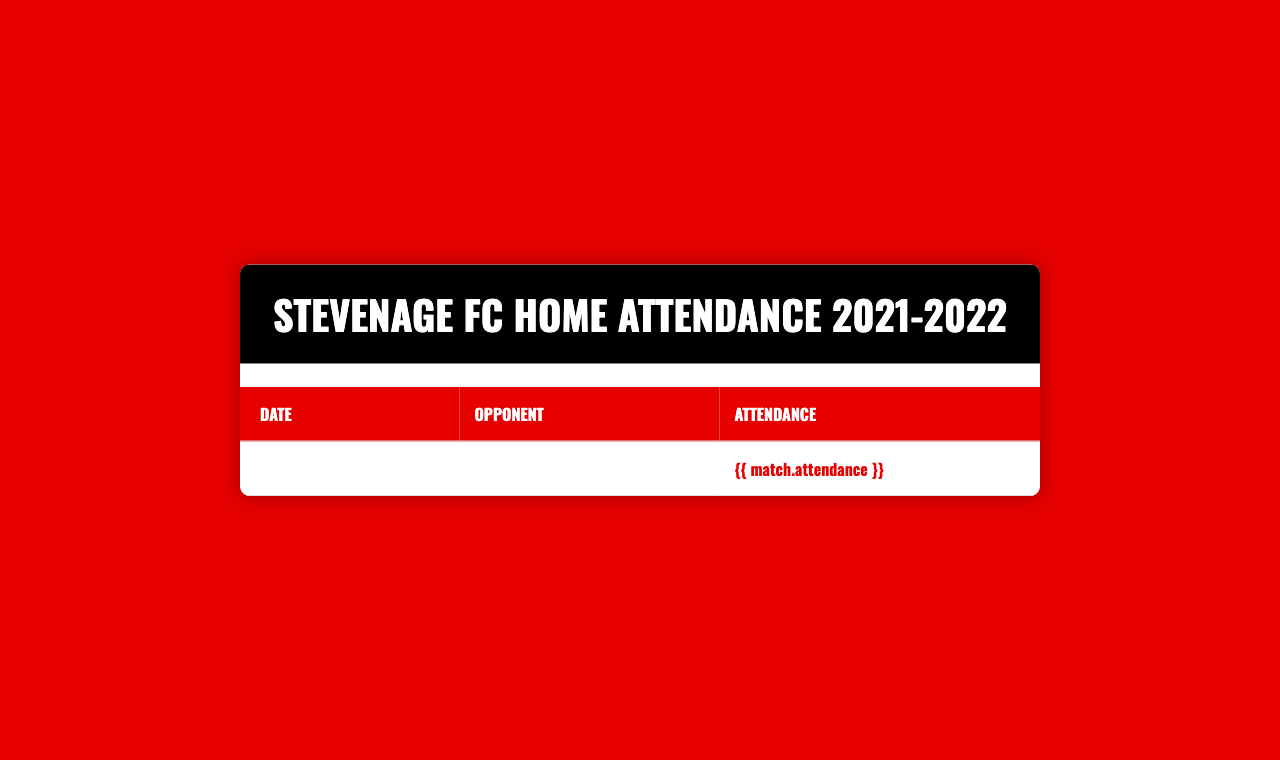What was the highest attendance in a home match? The table shows the attendance figures for each match. By inspecting the attendance column, the highest figure is 3567 for the match against Salford City on May 7, 2022.
Answer: 3567 When did Stevenage FC have the lowest attendance in the season? Looking through the attendance figures, the lowest attendance listed is 2754 for the match against Carlisle United on December 11, 2021.
Answer: December 11, 2021 What was the average attendance for the home matches? To calculate the average attendance, we first sum all the attendance figures: (2873 + 3012 + 3145 + 2956 + 3087 + 3256 + 2989 + 2801 + 2754 + 3421 + 2897 + 2765 + 2934 + 3178 + 3056 + 3298 + 3102 + 3345 + 3567) = 57547. Then, divide by the number of matches (18), which gives 57547/18 ≈ 3197.06.
Answer: ≈ 3197 Did Stevenage FC have an attendance of over 3000 at any match against Walsall? There are two matches against Walsall listed in the table: one on December 26, 2021, with an attendance of 3421, and another on January 15, 2022, with an attendance of 2897. The first match had an attendance over 3000, but the second did not.
Answer: Yes How many matches had an attendance of over 3000? We look at the attendance figures to count how many times the attendance is over 3000: Barrow (no), Port Vale (no), Swindon Town (no), Sutton United (no), Hartlepool United (no), Leyton Orient (yes), Colchester United (no), Scunthorpe United (no), Carlisle United (no), Walsall (yes), Harrogate Town (no), Crawley Town (no), Exeter City (yes), Oldham Athletic (yes), Forest Green Rovers (yes), Rochdale (yes), Tranmere Rovers (yes), and Salford City (yes). This makes a total of 9 matches where attendance was over 3000.
Answer: 9 During which match did Stevenage FC record a higher attendance: against Leyton Orient or Forest Green Rovers? Comparing the attendance figures for both matches, Leyton Orient had an attendance of 3256, while Forest Green Rovers had 3298. Forest Green Rovers had a higher attendance.
Answer: Forest Green Rovers What is the difference in attendance between the highest and lowest matches? The highest attendance is 3567 (Salford City) and the lowest is 2754 (Carlisle United). To find the difference, we calculate 3567 - 2754 = 813.
Answer: 813 Which opponent had the closest attendance to 3000? We check the attendance figures for proximity to 3000. The closest figures are Colchester United with 2989 (11 under) and Hartlepool United with 3087 (87 over). Colchester United is the closest.
Answer: Colchester United How many matches were played on or after January 1, 2022, that had an attendance less than 3000? Reviewing the matches starting from January 1, 2022, we find Walsall on January 15 with an attendance of 2897, and Harrogate Town on January 29 with an attendance of 2765, both under 3000. There are 2 matches with this attendance criterion.
Answer: 2 Was there a match against Scunthorpe United with attendance less than 3000? Yes, looking at the attendance figure for Scunthorpe United, which is 2801, confirms that it was indeed less than 3000.
Answer: Yes 